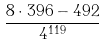<formula> <loc_0><loc_0><loc_500><loc_500>\frac { 8 \cdot 3 9 6 - 4 9 2 } { 4 ^ { 1 1 9 } }</formula> 